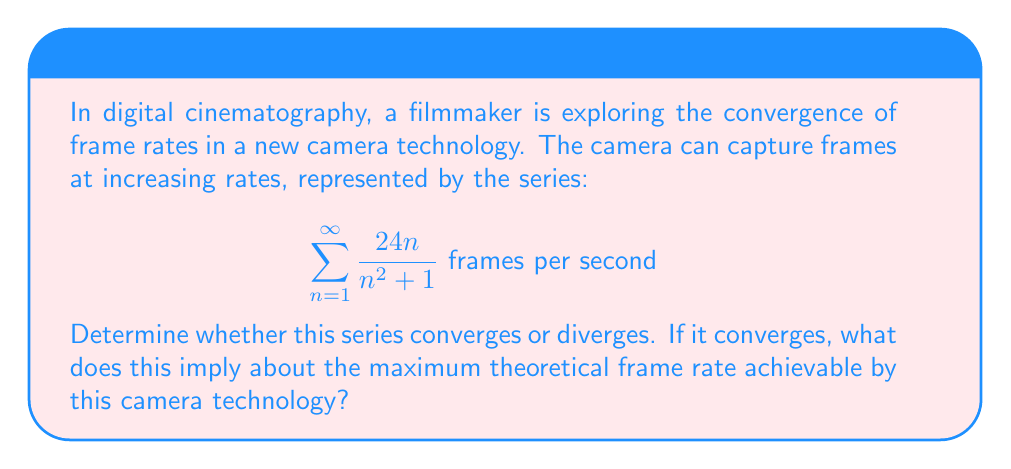Provide a solution to this math problem. Let's approach this step-by-step:

1) First, we need to examine the general term of the series:
   $$a_n = \frac{24n}{n^2 + 1}$$

2) To determine convergence, we can use the limit comparison test with the series $\sum \frac{1}{n}$, which is known to diverge.

3) Let's compute the limit of the ratio of our series term to $\frac{1}{n}$:

   $$\lim_{n \to \infty} \frac{a_n}{\frac{1}{n}} = \lim_{n \to \infty} \frac{\frac{24n}{n^2 + 1}}{\frac{1}{n}} = \lim_{n \to \infty} \frac{24n^2}{n^2 + 1}$$

4) Simplify:
   $$\lim_{n \to \infty} \frac{24n^2}{n^2 + 1} = \lim_{n \to \infty} \frac{24}{1 + \frac{1}{n^2}} = 24$$

5) Since this limit is a non-zero finite number (24), by the limit comparison test, our series behaves the same way as $\sum \frac{1}{n}$.

6) We know that $\sum \frac{1}{n}$ diverges (it's the harmonic series), so our series also diverges.

7) In the context of cinematography, this divergence implies that there's no theoretical upper limit to the frame rate achievable by this camera technology. As n approaches infinity, the camera could theoretically capture an infinite number of frames per second.

8) However, in practical terms, there would be physical limitations preventing an actual infinite frame rate. The divergence of the series suggests that the technology allows for continual increases in frame rate without a fixed upper bound.
Answer: The series diverges, implying no theoretical maximum frame rate. 